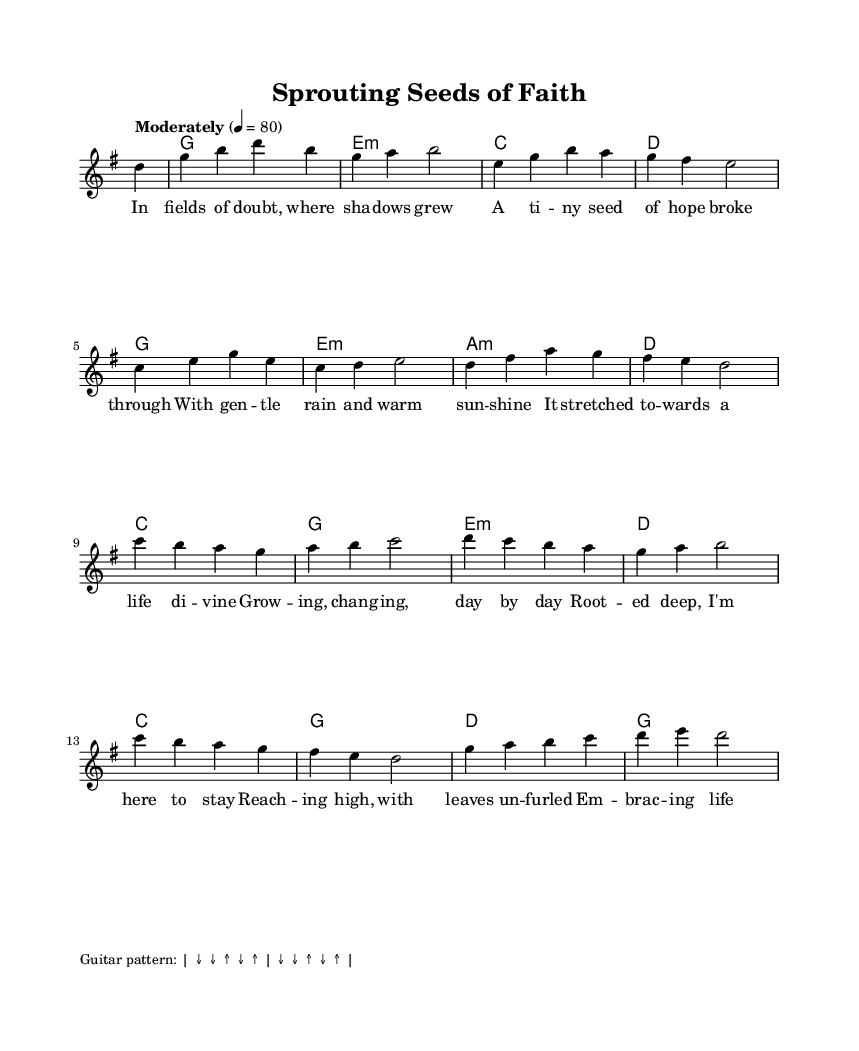What key is this piece written in? The music is in G major, indicated by the key signature that has one sharp (F#).
Answer: G major What is the time signature of this piece? The time signature is shown at the beginning as 4/4, which means there are four beats in each measure.
Answer: 4/4 What is the tempo marking for this piece? The tempo marking is indicated as "Moderately" with a beat of 80 per minute, which guides the speed of the performance.
Answer: Moderately How many measures are in the melody? By counting the measures in the melody, there are 16 measures total, indicated by the four-bar phrases and the layout.
Answer: 16 What is the main theme of the song as reflected in the lyrics? The lyrics discuss themes of growth and new beginnings, characterized by metaphors of seeds and nature, conveying a sense of hope.
Answer: Growth and new beginnings What style of music is this piece categorized under? This piece falls under the category of acoustic folk hymns, as suggested by its religious themes and folk style characteristics present in the melody and lyrics.
Answer: Acoustic folk hymns How do the harmonies complement the melody? The harmonies provide a foundational support that enhances the melody, with chords aligning with the melodic notes to create a rich harmonic texture throughout the piece.
Answer: They enhance the melody 